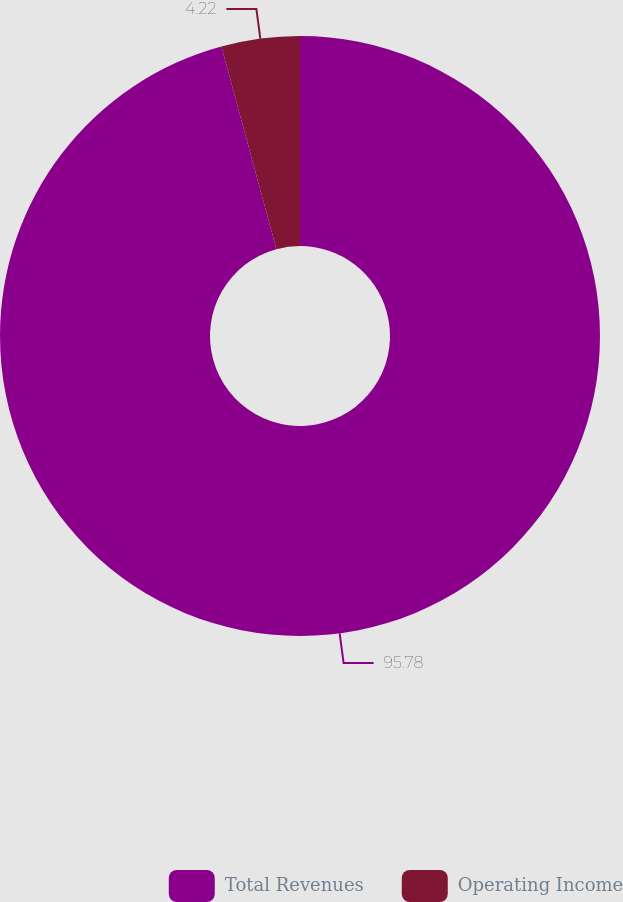Convert chart. <chart><loc_0><loc_0><loc_500><loc_500><pie_chart><fcel>Total Revenues<fcel>Operating Income<nl><fcel>95.78%<fcel>4.22%<nl></chart> 